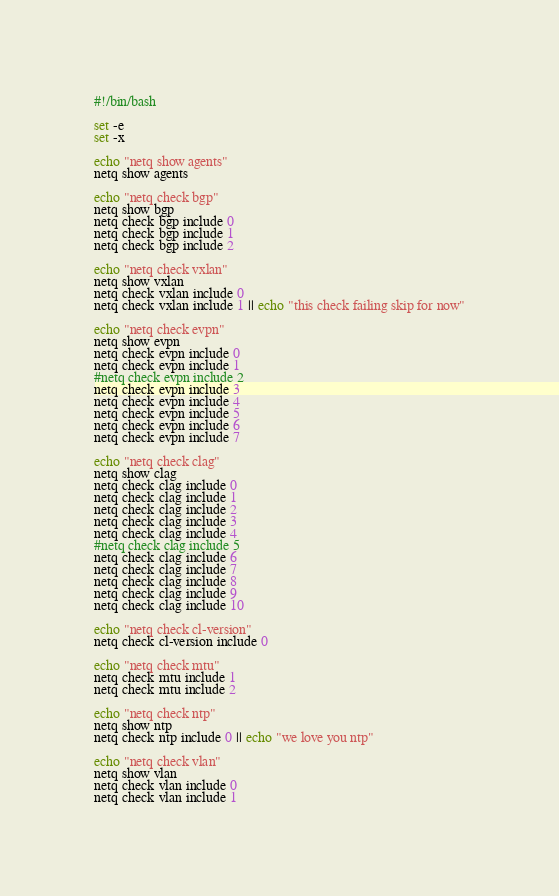Convert code to text. <code><loc_0><loc_0><loc_500><loc_500><_Bash_>#!/bin/bash

set -e
set -x

echo "netq show agents"
netq show agents

echo "netq check bgp"
netq show bgp
netq check bgp include 0
netq check bgp include 1
netq check bgp include 2

echo "netq check vxlan"
netq show vxlan
netq check vxlan include 0
netq check vxlan include 1 || echo "this check failing skip for now"

echo "netq check evpn"
netq show evpn
netq check evpn include 0
netq check evpn include 1
#netq check evpn include 2
netq check evpn include 3
netq check evpn include 4
netq check evpn include 5
netq check evpn include 6
netq check evpn include 7 

echo "netq check clag"
netq show clag
netq check clag include 0
netq check clag include 1
netq check clag include 2
netq check clag include 3
netq check clag include 4
#netq check clag include 5
netq check clag include 6
netq check clag include 7
netq check clag include 8
netq check clag include 9
netq check clag include 10

echo "netq check cl-version"
netq check cl-version include 0

echo "netq check mtu"
netq check mtu include 1
netq check mtu include 2

echo "netq check ntp"
netq show ntp
netq check ntp include 0 || echo "we love you ntp"

echo "netq check vlan"
netq show vlan
netq check vlan include 0
netq check vlan include 1
</code> 